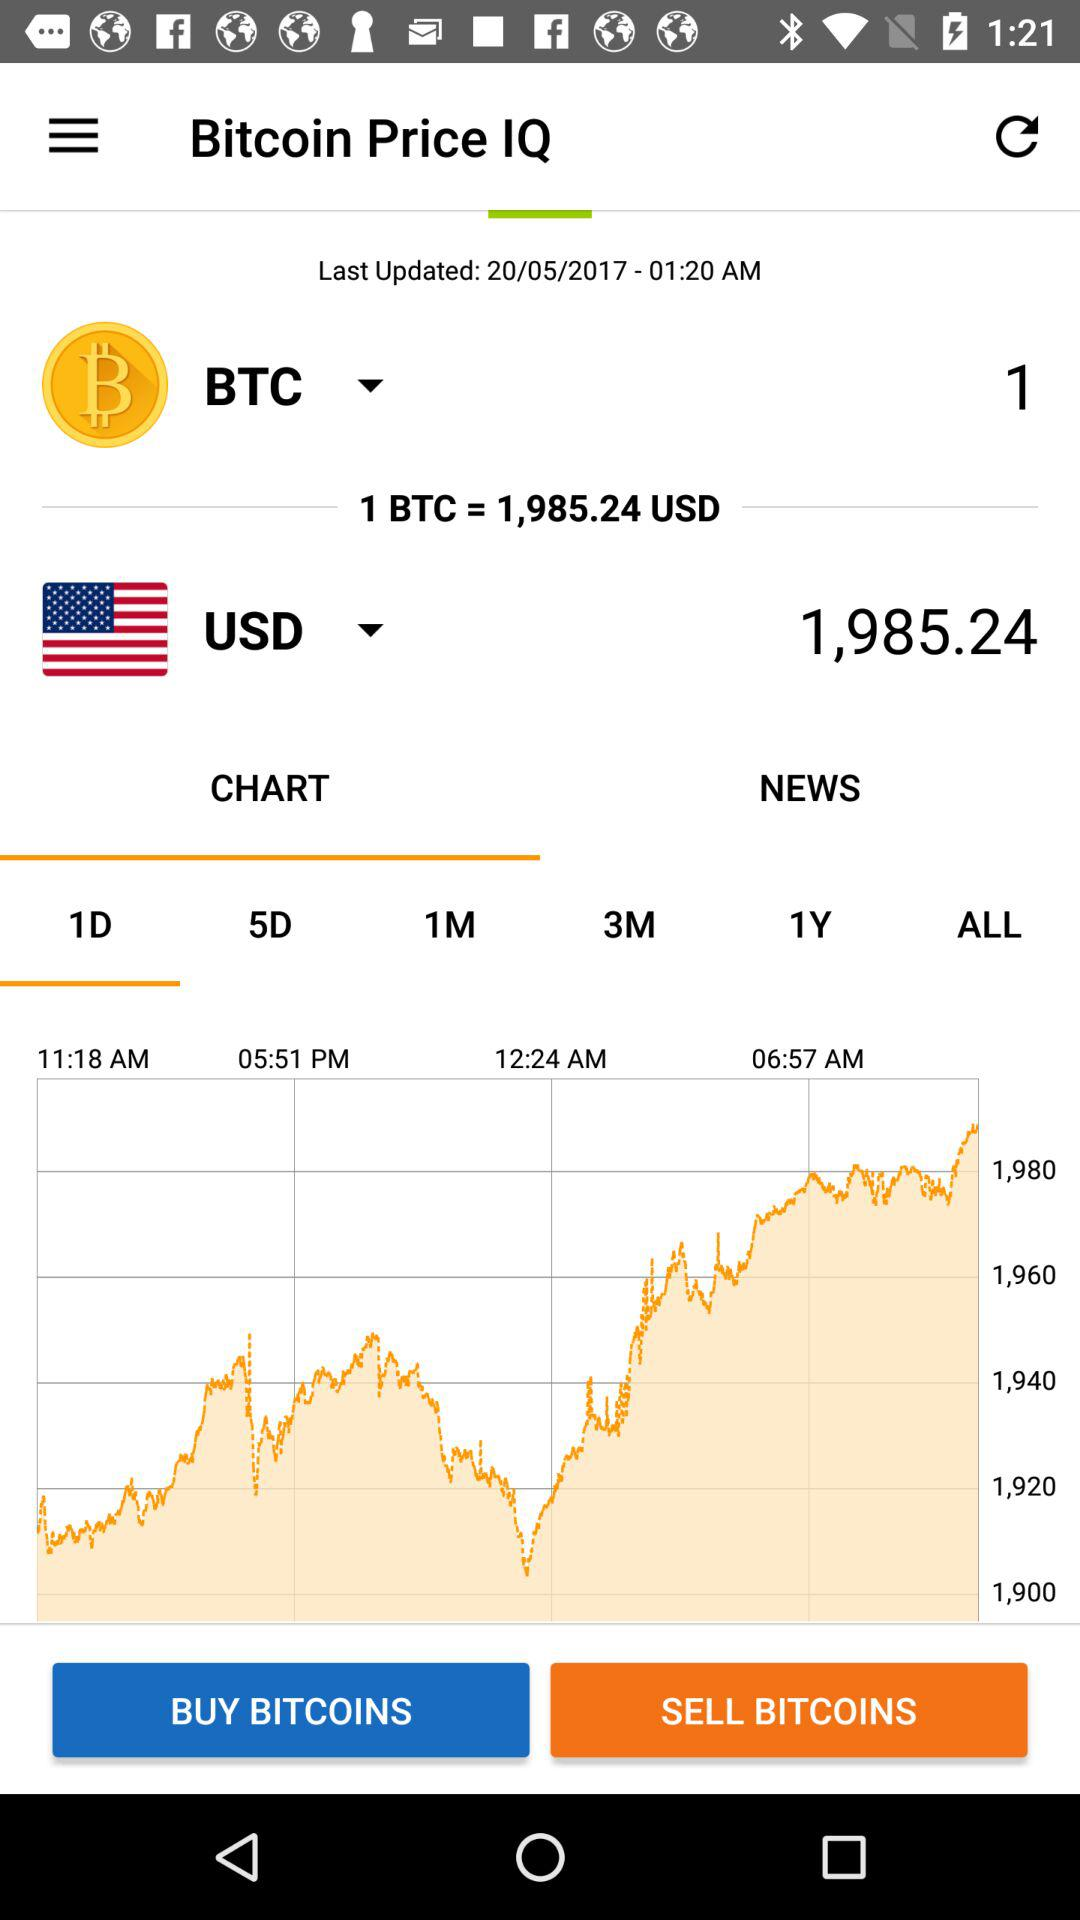What is the USD price of 1 BTC?
Answer the question using a single word or phrase. 1,985.24 